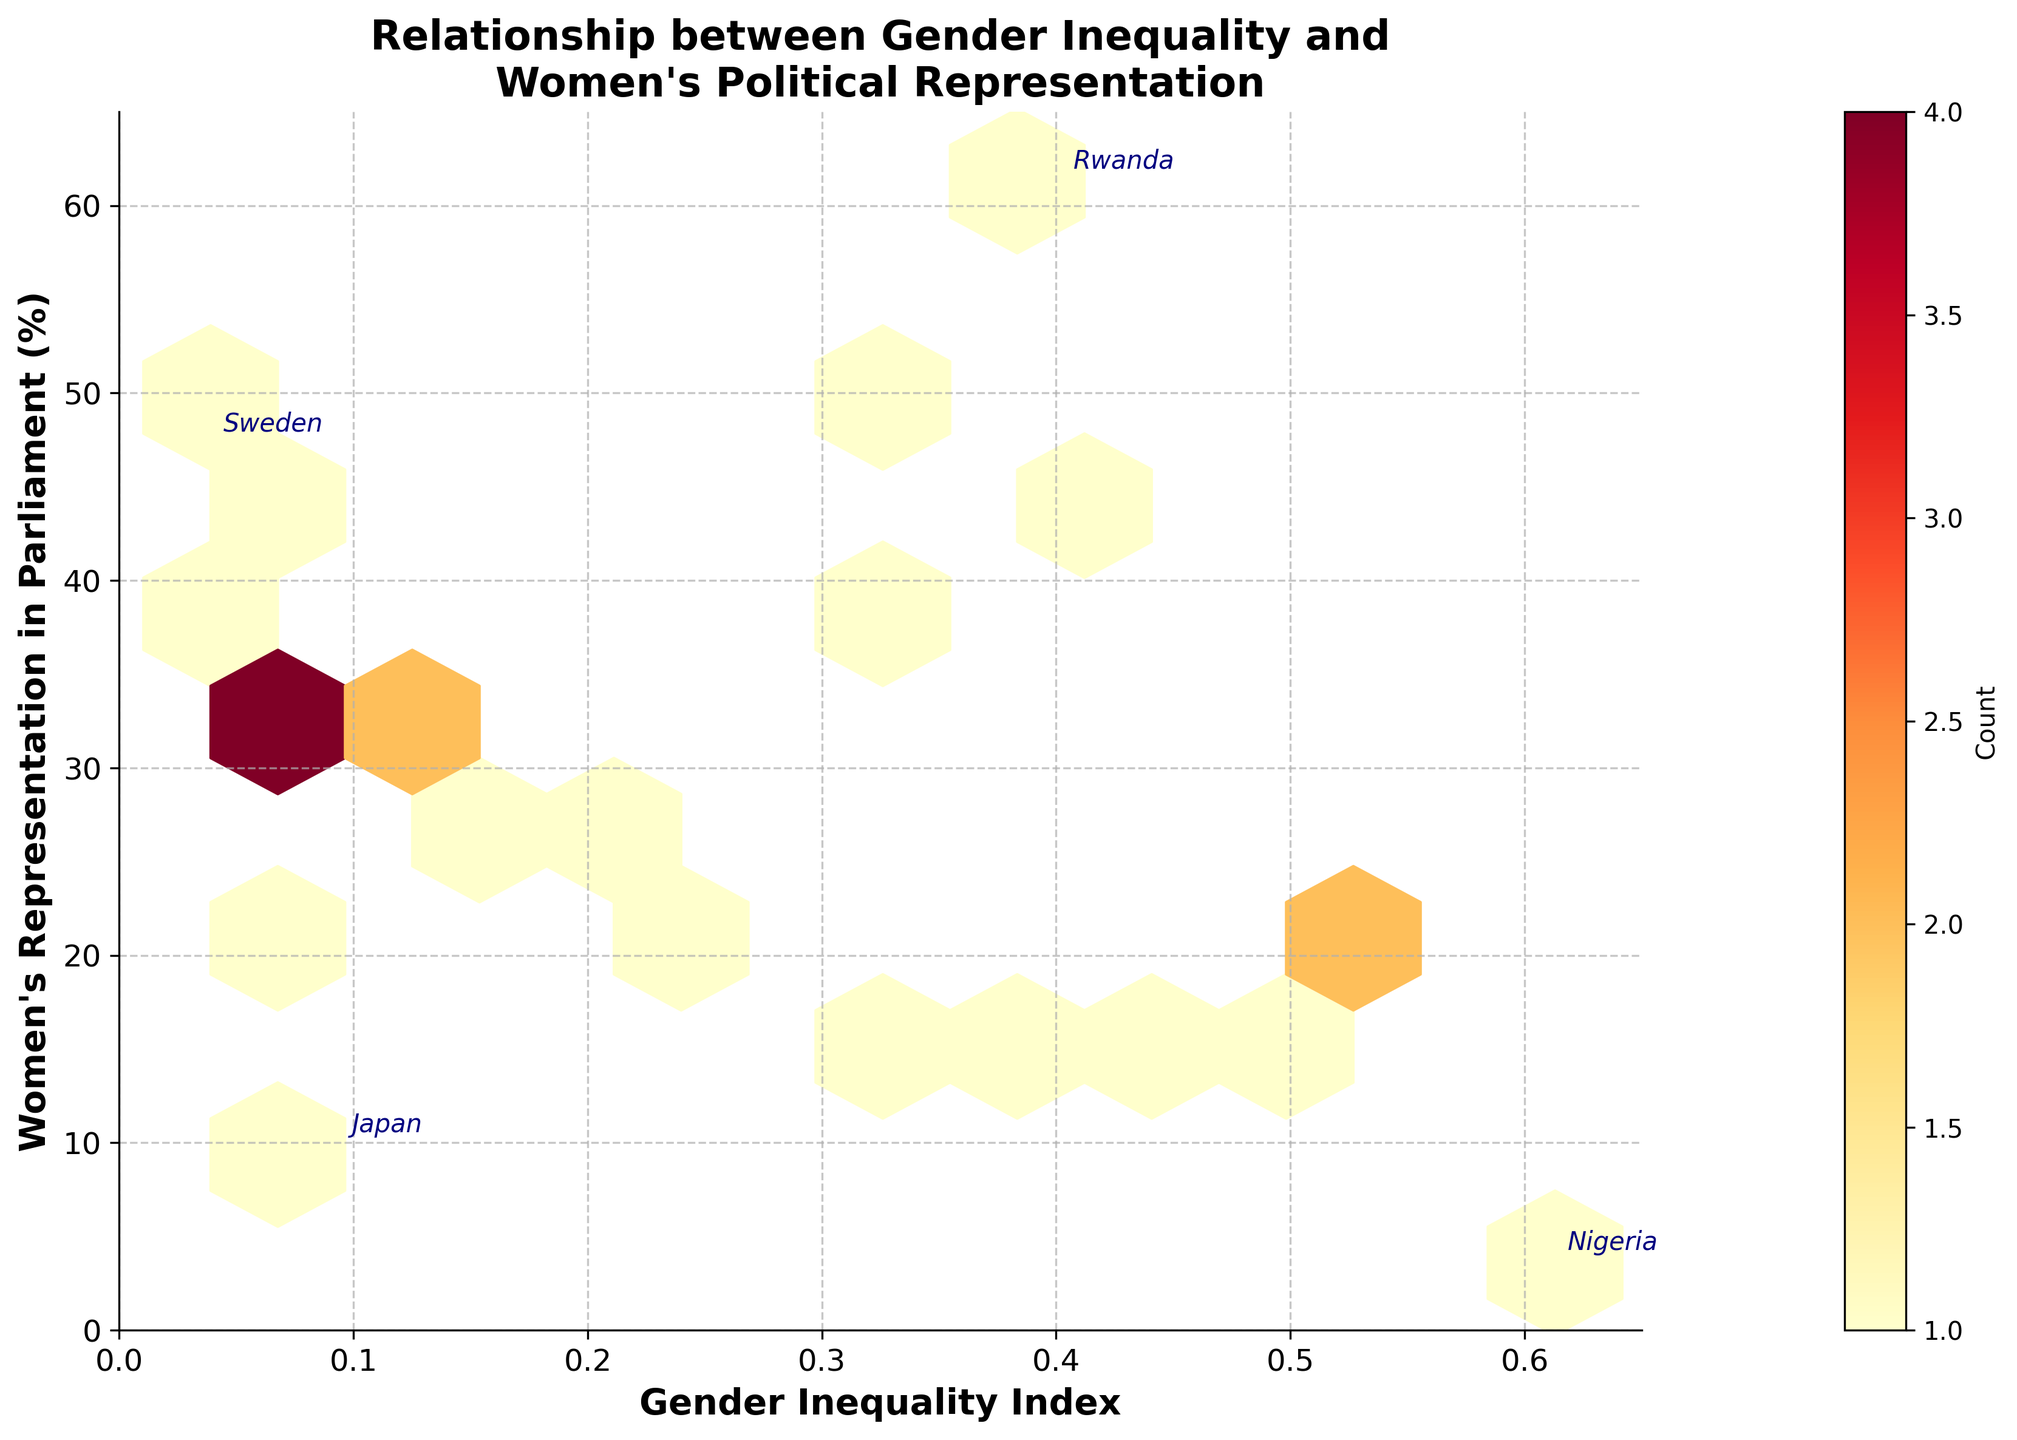What is the title of the hexbin plot? The title of the plot is displayed at the top-center of the figure. It reads "Relationship between Gender Inequality and Women's Political Representation".
Answer: Relationship between Gender Inequality and Women's Political Representation What are the labeled axes in the plot? The x-axis is labeled "Gender Inequality Index," and the y-axis is labeled "Women's Representation in Parliament (%)". The labels are in a bold and readable font.
Answer: Gender Inequality Index; Women's Representation in Parliament (%) Which countries are explicitly annotated in the figure? Four countries have their names explicitly annotated: Rwanda, Sweden, Japan, and Nigeria. These annotations are placed near the corresponding data points and are made for countries of particular interest or extremity in the data.
Answer: Rwanda, Sweden, Japan, Nigeria How many hexagons have counts greater than or equal to 2? Counting the hexagons with a color intensity suggestive of a higher count and confirmed by the color bar, there are 5 hexagons that display a count of 2 or more.
Answer: 5 What is the color gradient used in the hexbin plot? The hexagons follow a gradient from yellow to orange to red, indicating increasing counts as per the color bar legend that ranges from lighter to darker shades.
Answer: Yellow to red Which countries have a Gender Inequality Index above 0.5? By examining the x-axis and looking for data points to the right of the 0.5 mark, there are two countries: Nigeria and Kenya.
Answer: Nigeria, Kenya Which country has the highest percentage of women in parliament? Observing the y-axis and identifying the data point at the highest percentage, Rwanda has the highest percentage of women in parliament at 61.3%.
Answer: Rwanda How does the Women's Representation in Parliament (%) in Sweden compare to that in the United States? Sweden's percentage is at 47.3%, while the United States is at 27.3%. Sweden has a substantially higher percentage of women in parliament compared to the United States.
Answer: Sweden has a higher percentage Is there a general trend between Gender Inequality Index and Women's Representation in Parliament (%)? Visually inspecting the plot, there seems to be a slightly negative correlation where higher gender inequality often corresponds to lower percentages of women in parliament.
Answer: Slightly negative correlation Which pair of countries has the lowest and the highest Gender Inequality Index? The country with the lowest Gender Inequality Index is Sweden (0.039), and the country with the highest is Nigeria (0.613). These values represent extremes on the x-axis.
Answer: Sweden and Nigeria 